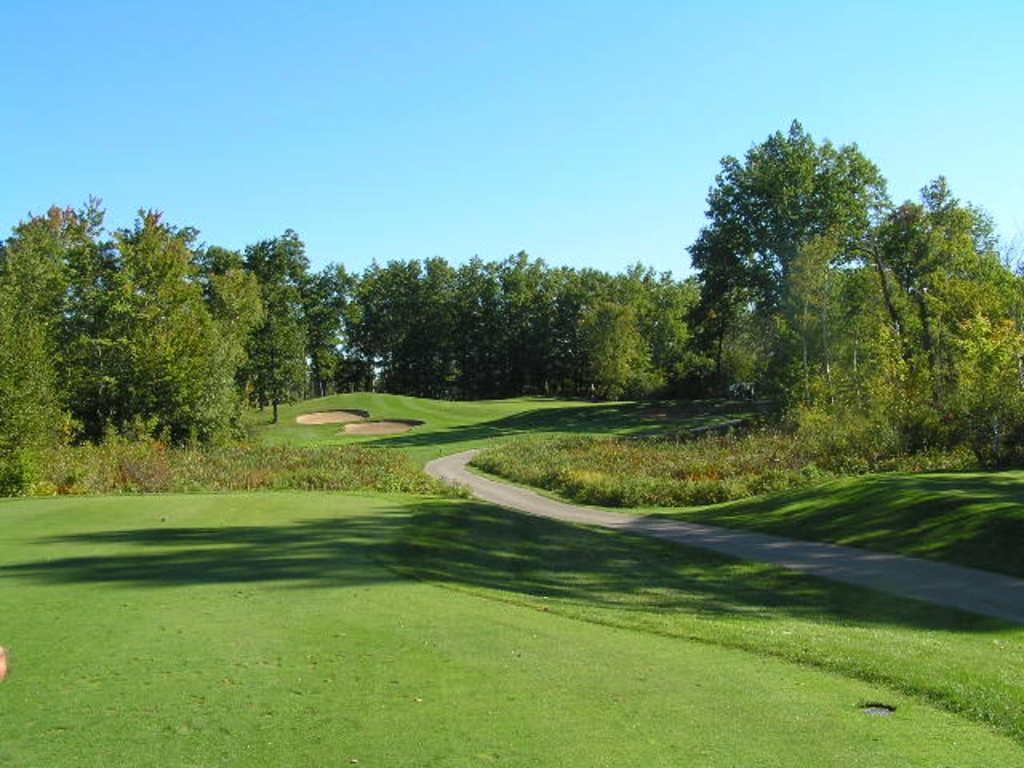Describe this image in one or two sentences. In this image we can see one big garden, one object on the surface, one road middle of the garden, some trees, bushes, plants and green grass on the ground. At the top there is the sky. 